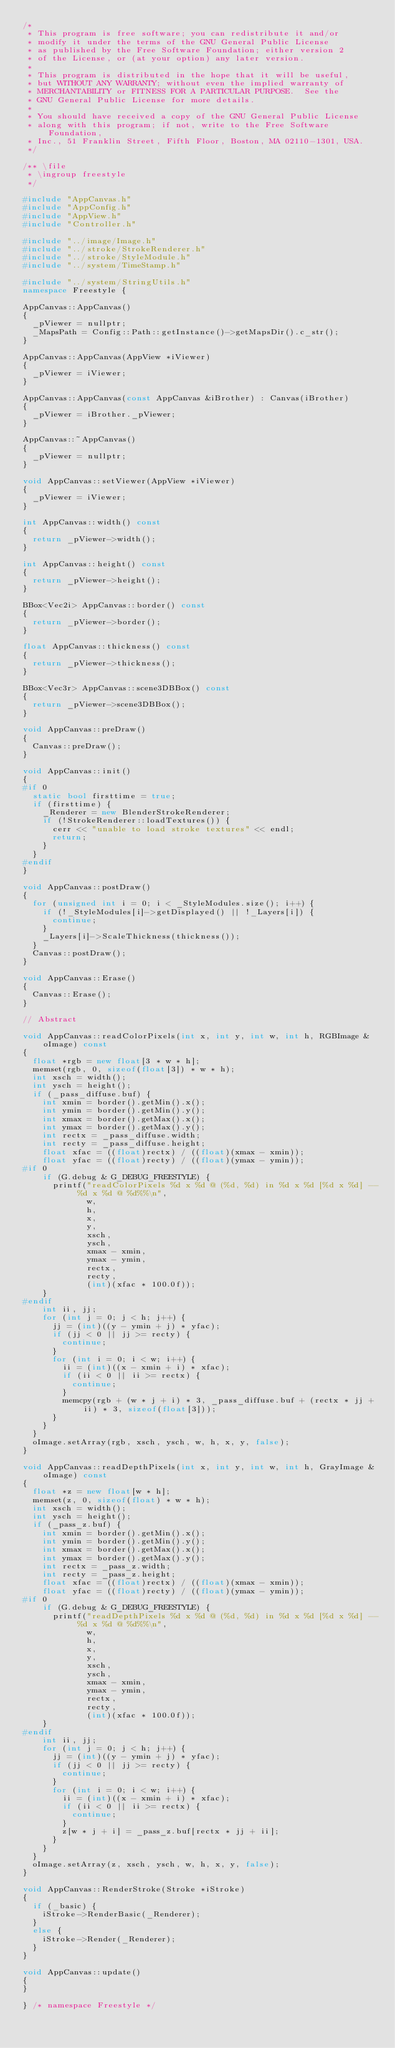Convert code to text. <code><loc_0><loc_0><loc_500><loc_500><_C++_>/*
 * This program is free software; you can redistribute it and/or
 * modify it under the terms of the GNU General Public License
 * as published by the Free Software Foundation; either version 2
 * of the License, or (at your option) any later version.
 *
 * This program is distributed in the hope that it will be useful,
 * but WITHOUT ANY WARRANTY; without even the implied warranty of
 * MERCHANTABILITY or FITNESS FOR A PARTICULAR PURPOSE.  See the
 * GNU General Public License for more details.
 *
 * You should have received a copy of the GNU General Public License
 * along with this program; if not, write to the Free Software Foundation,
 * Inc., 51 Franklin Street, Fifth Floor, Boston, MA 02110-1301, USA.
 */

/** \file
 * \ingroup freestyle
 */

#include "AppCanvas.h"
#include "AppConfig.h"
#include "AppView.h"
#include "Controller.h"

#include "../image/Image.h"
#include "../stroke/StrokeRenderer.h"
#include "../stroke/StyleModule.h"
#include "../system/TimeStamp.h"

#include "../system/StringUtils.h"
namespace Freestyle {

AppCanvas::AppCanvas()
{
  _pViewer = nullptr;
  _MapsPath = Config::Path::getInstance()->getMapsDir().c_str();
}

AppCanvas::AppCanvas(AppView *iViewer)
{
  _pViewer = iViewer;
}

AppCanvas::AppCanvas(const AppCanvas &iBrother) : Canvas(iBrother)
{
  _pViewer = iBrother._pViewer;
}

AppCanvas::~AppCanvas()
{
  _pViewer = nullptr;
}

void AppCanvas::setViewer(AppView *iViewer)
{
  _pViewer = iViewer;
}

int AppCanvas::width() const
{
  return _pViewer->width();
}

int AppCanvas::height() const
{
  return _pViewer->height();
}

BBox<Vec2i> AppCanvas::border() const
{
  return _pViewer->border();
}

float AppCanvas::thickness() const
{
  return _pViewer->thickness();
}

BBox<Vec3r> AppCanvas::scene3DBBox() const
{
  return _pViewer->scene3DBBox();
}

void AppCanvas::preDraw()
{
  Canvas::preDraw();
}

void AppCanvas::init()
{
#if 0
  static bool firsttime = true;
  if (firsttime) {
    _Renderer = new BlenderStrokeRenderer;
    if (!StrokeRenderer::loadTextures()) {
      cerr << "unable to load stroke textures" << endl;
      return;
    }
  }
#endif
}

void AppCanvas::postDraw()
{
  for (unsigned int i = 0; i < _StyleModules.size(); i++) {
    if (!_StyleModules[i]->getDisplayed() || !_Layers[i]) {
      continue;
    }
    _Layers[i]->ScaleThickness(thickness());
  }
  Canvas::postDraw();
}

void AppCanvas::Erase()
{
  Canvas::Erase();
}

// Abstract

void AppCanvas::readColorPixels(int x, int y, int w, int h, RGBImage &oImage) const
{
  float *rgb = new float[3 * w * h];
  memset(rgb, 0, sizeof(float[3]) * w * h);
  int xsch = width();
  int ysch = height();
  if (_pass_diffuse.buf) {
    int xmin = border().getMin().x();
    int ymin = border().getMin().y();
    int xmax = border().getMax().x();
    int ymax = border().getMax().y();
    int rectx = _pass_diffuse.width;
    int recty = _pass_diffuse.height;
    float xfac = ((float)rectx) / ((float)(xmax - xmin));
    float yfac = ((float)recty) / ((float)(ymax - ymin));
#if 0
    if (G.debug & G_DEBUG_FREESTYLE) {
      printf("readColorPixels %d x %d @ (%d, %d) in %d x %d [%d x %d] -- %d x %d @ %d%%\n",
             w,
             h,
             x,
             y,
             xsch,
             ysch,
             xmax - xmin,
             ymax - ymin,
             rectx,
             recty,
             (int)(xfac * 100.0f));
    }
#endif
    int ii, jj;
    for (int j = 0; j < h; j++) {
      jj = (int)((y - ymin + j) * yfac);
      if (jj < 0 || jj >= recty) {
        continue;
      }
      for (int i = 0; i < w; i++) {
        ii = (int)((x - xmin + i) * xfac);
        if (ii < 0 || ii >= rectx) {
          continue;
        }
        memcpy(rgb + (w * j + i) * 3, _pass_diffuse.buf + (rectx * jj + ii) * 3, sizeof(float[3]));
      }
    }
  }
  oImage.setArray(rgb, xsch, ysch, w, h, x, y, false);
}

void AppCanvas::readDepthPixels(int x, int y, int w, int h, GrayImage &oImage) const
{
  float *z = new float[w * h];
  memset(z, 0, sizeof(float) * w * h);
  int xsch = width();
  int ysch = height();
  if (_pass_z.buf) {
    int xmin = border().getMin().x();
    int ymin = border().getMin().y();
    int xmax = border().getMax().x();
    int ymax = border().getMax().y();
    int rectx = _pass_z.width;
    int recty = _pass_z.height;
    float xfac = ((float)rectx) / ((float)(xmax - xmin));
    float yfac = ((float)recty) / ((float)(ymax - ymin));
#if 0
    if (G.debug & G_DEBUG_FREESTYLE) {
      printf("readDepthPixels %d x %d @ (%d, %d) in %d x %d [%d x %d] -- %d x %d @ %d%%\n",
             w,
             h,
             x,
             y,
             xsch,
             ysch,
             xmax - xmin,
             ymax - ymin,
             rectx,
             recty,
             (int)(xfac * 100.0f));
    }
#endif
    int ii, jj;
    for (int j = 0; j < h; j++) {
      jj = (int)((y - ymin + j) * yfac);
      if (jj < 0 || jj >= recty) {
        continue;
      }
      for (int i = 0; i < w; i++) {
        ii = (int)((x - xmin + i) * xfac);
        if (ii < 0 || ii >= rectx) {
          continue;
        }
        z[w * j + i] = _pass_z.buf[rectx * jj + ii];
      }
    }
  }
  oImage.setArray(z, xsch, ysch, w, h, x, y, false);
}

void AppCanvas::RenderStroke(Stroke *iStroke)
{
  if (_basic) {
    iStroke->RenderBasic(_Renderer);
  }
  else {
    iStroke->Render(_Renderer);
  }
}

void AppCanvas::update()
{
}

} /* namespace Freestyle */
</code> 